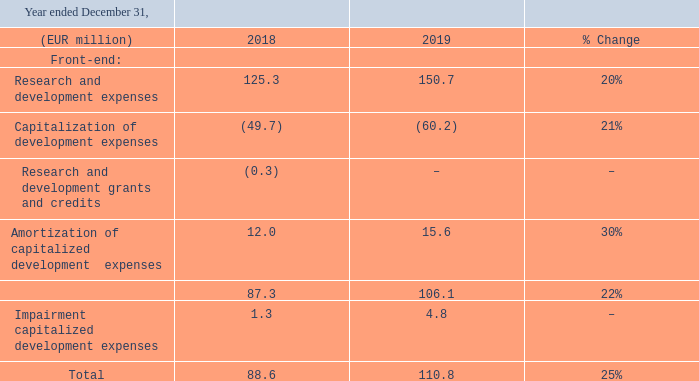RESEARCH AND DEVELOPMENT EXPENSES
Total research and development (R&D) expenses, excluding impairment charges, increased by 22% in 2019 compared to the previous year, mainly as a result of higher development activities. As a percentage of sales (excluding the patent litigation & arbitration settlement), R&D expenses decreased to 10% compared to 11% in 2018. Currency changes resulted in a 4% increase in R&D expenses year-over-year.
Total research and development expenses developed as follows:
Impairment of capitalized development expenses related primarily to the development of new technology that is now no longer in-demand from customers.
We continue to invest strongly in R&D. As part of our R&D activities, we are engaged in various development programs with customers and research institutes. These allow us to develop products that meet customer requirements and obtain access to new technology and expertise. The costs relating to prototypes and experimental models, which we may subsequently sell to customers, are charged to the cost of sales.
Our R&D operations in the Netherlands, Belgium, and the United States receive research and development grants and credits from various sources.
Where are the R&D operations located for the company? Netherlands, belgium, the united states. What are the years included in the table for Total research and development expenses? 2018, 2019. What is the R&D expense as a percentage of sales in 2019? 10%. For 2019, What is the segment of Front-end that has the highest expense amount? For COL4 rows 4 to 7 and row 9, find the largest number and the corresponding segment in COL2
Answer: research and development expenses. What is the change in total research and development expenses from 2018 to 2019?
Answer scale should be: million. 110.8-88.6
Answer: 22.2. For 2019, what is the  Research and development expenses and  Capitalization of development expenses expressed as a percentage of total research and development expenses?
Answer scale should be: percent. (150.7+(-60.2))/110.8
Answer: 81.68. 